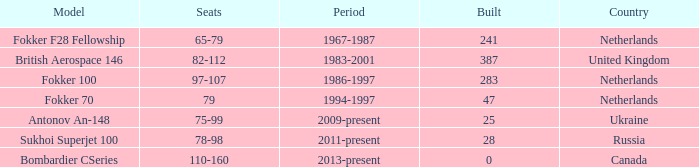How many cabins were erected during the years 1967-1987? 241.0. 